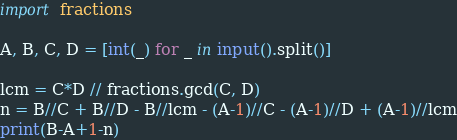Convert code to text. <code><loc_0><loc_0><loc_500><loc_500><_Python_>import fractions

A, B, C, D = [int(_) for _ in input().split()]

lcm = C*D // fractions.gcd(C, D)
n = B//C + B//D - B//lcm - (A-1)//C - (A-1)//D + (A-1)//lcm
print(B-A+1-n)
</code> 